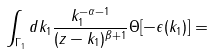<formula> <loc_0><loc_0><loc_500><loc_500>\int _ { \Gamma _ { 1 } } d k _ { 1 } \frac { k _ { 1 } ^ { - \alpha - 1 } } { ( z - k _ { 1 } ) ^ { \beta + 1 } } \Theta [ - \epsilon ( k _ { 1 } ) ] =</formula> 